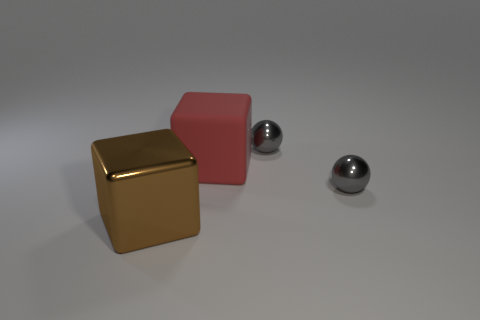Add 1 gray objects. How many objects exist? 5 Subtract 0 yellow cubes. How many objects are left? 4 Subtract all large red rubber cubes. Subtract all large blue shiny cylinders. How many objects are left? 3 Add 3 large metallic cubes. How many large metallic cubes are left? 4 Add 3 large matte cubes. How many large matte cubes exist? 4 